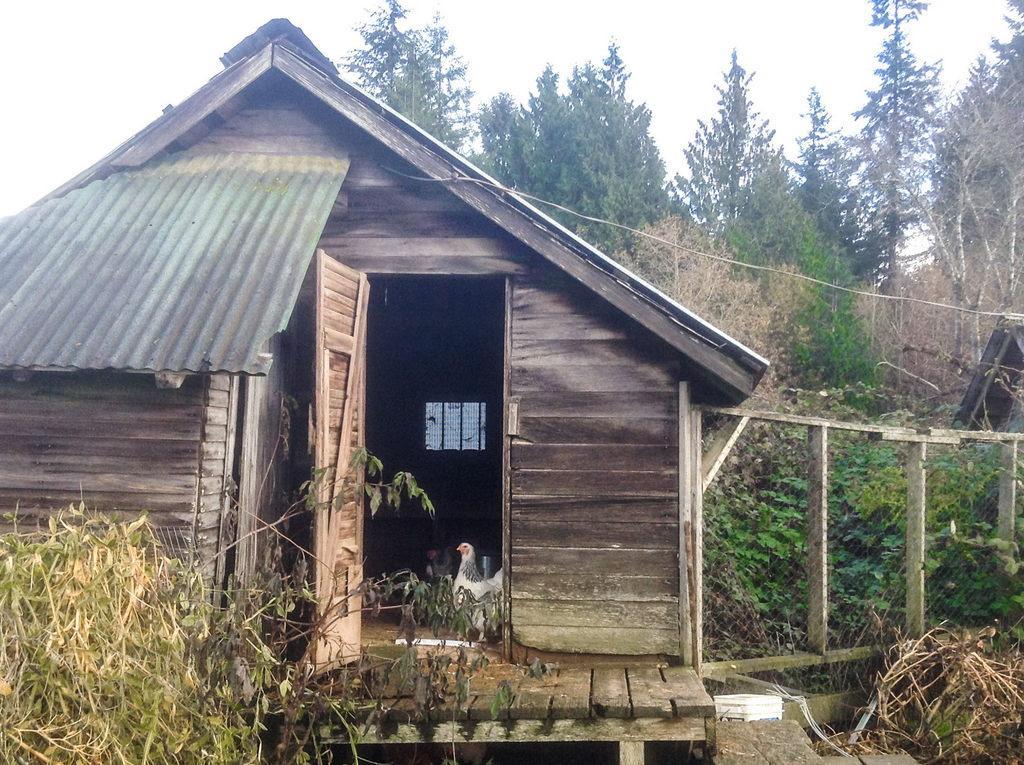Can you describe this image briefly? In this picture we can see a few plants on the left side. There is a hen in the wooden house. We can see a door and a metal roofing sheet on the left side. There is some fencing, plants and a few trees are visible in the background. 